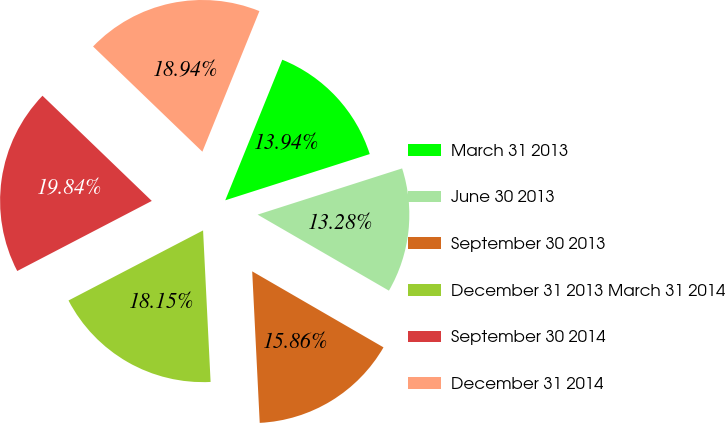<chart> <loc_0><loc_0><loc_500><loc_500><pie_chart><fcel>March 31 2013<fcel>June 30 2013<fcel>September 30 2013<fcel>December 31 2013 March 31 2014<fcel>September 30 2014<fcel>December 31 2014<nl><fcel>13.94%<fcel>13.28%<fcel>15.86%<fcel>18.15%<fcel>19.84%<fcel>18.94%<nl></chart> 